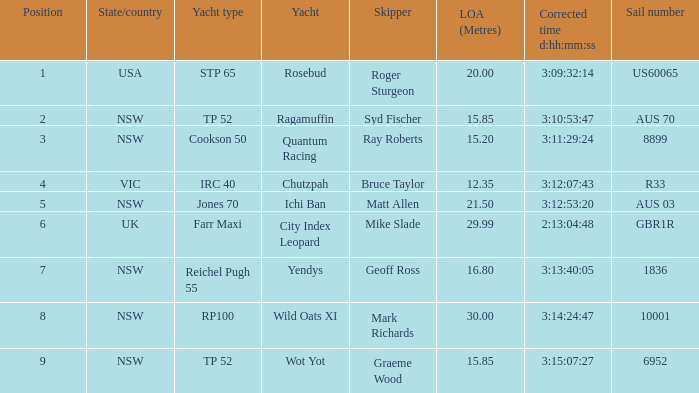What are all of the states or countries with a corrected time 3:13:40:05? NSW. Could you parse the entire table? {'header': ['Position', 'State/country', 'Yacht type', 'Yacht', 'Skipper', 'LOA (Metres)', 'Corrected time d:hh:mm:ss', 'Sail number'], 'rows': [['1', 'USA', 'STP 65', 'Rosebud', 'Roger Sturgeon', '20.00', '3:09:32:14', 'US60065'], ['2', 'NSW', 'TP 52', 'Ragamuffin', 'Syd Fischer', '15.85', '3:10:53:47', 'AUS 70'], ['3', 'NSW', 'Cookson 50', 'Quantum Racing', 'Ray Roberts', '15.20', '3:11:29:24', '8899'], ['4', 'VIC', 'IRC 40', 'Chutzpah', 'Bruce Taylor', '12.35', '3:12:07:43', 'R33'], ['5', 'NSW', 'Jones 70', 'Ichi Ban', 'Matt Allen', '21.50', '3:12:53:20', 'AUS 03'], ['6', 'UK', 'Farr Maxi', 'City Index Leopard', 'Mike Slade', '29.99', '2:13:04:48', 'GBR1R'], ['7', 'NSW', 'Reichel Pugh 55', 'Yendys', 'Geoff Ross', '16.80', '3:13:40:05', '1836'], ['8', 'NSW', 'RP100', 'Wild Oats XI', 'Mark Richards', '30.00', '3:14:24:47', '10001'], ['9', 'NSW', 'TP 52', 'Wot Yot', 'Graeme Wood', '15.85', '3:15:07:27', '6952']]} 